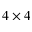Convert formula to latex. <formula><loc_0><loc_0><loc_500><loc_500>4 \times 4</formula> 